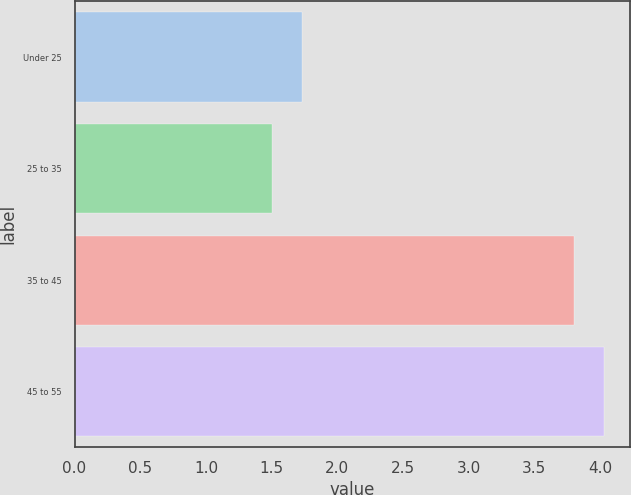Convert chart to OTSL. <chart><loc_0><loc_0><loc_500><loc_500><bar_chart><fcel>Under 25<fcel>25 to 35<fcel>35 to 45<fcel>45 to 55<nl><fcel>1.73<fcel>1.5<fcel>3.8<fcel>4.03<nl></chart> 